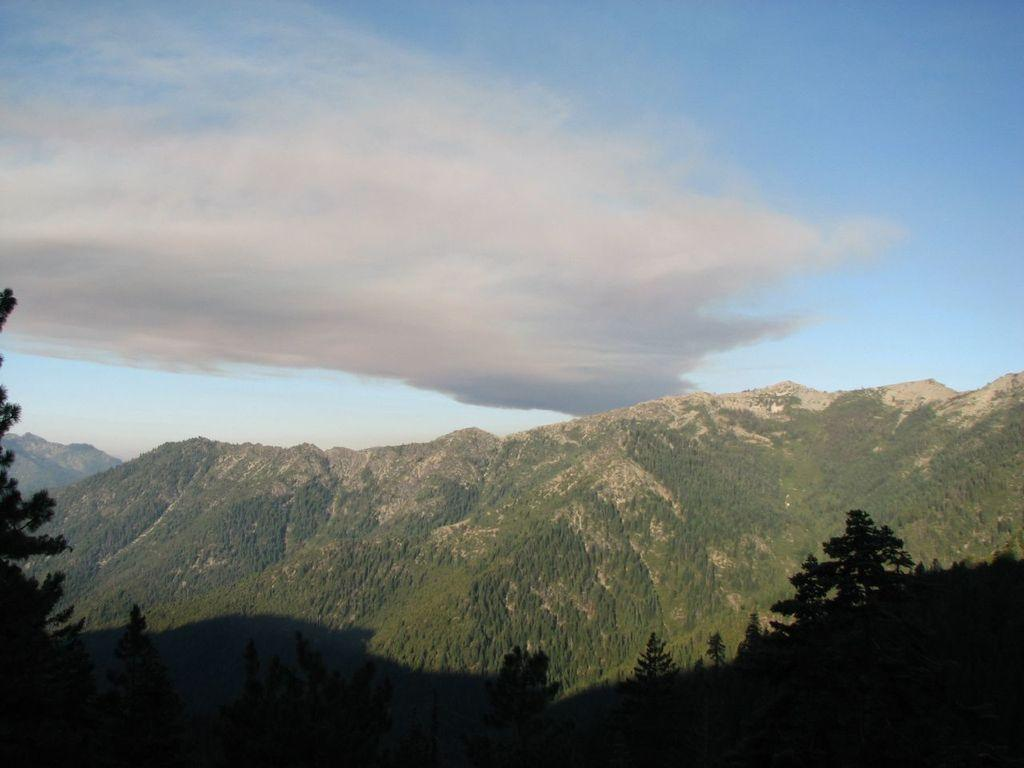What type of landscape is depicted in the image? The image features hills. What other natural elements can be seen in the image? There are trees in the image. What is visible in the background of the image? The sky is visible in the background of the image. How many elbows can be seen in the image? There are no elbows present in the image, as it features a landscape with hills and trees. 